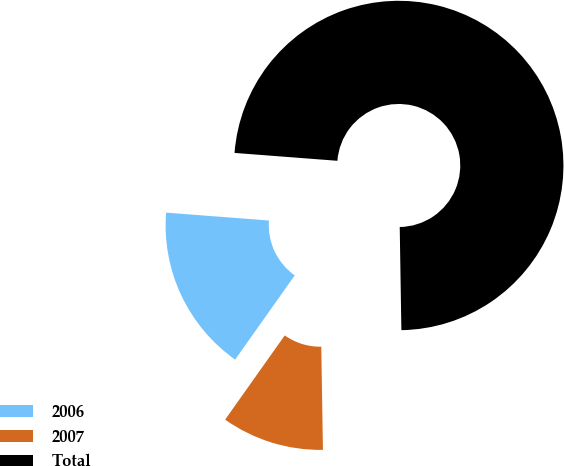Convert chart. <chart><loc_0><loc_0><loc_500><loc_500><pie_chart><fcel>2006<fcel>2007<fcel>Total<nl><fcel>16.41%<fcel>10.06%<fcel>73.53%<nl></chart> 